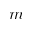<formula> <loc_0><loc_0><loc_500><loc_500>m</formula> 